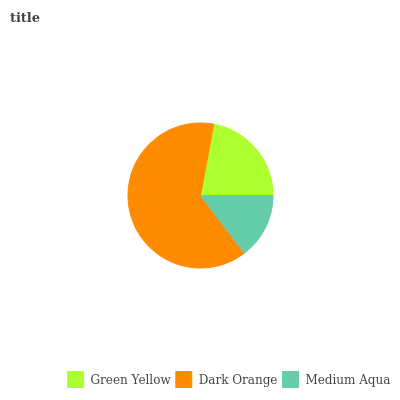Is Medium Aqua the minimum?
Answer yes or no. Yes. Is Dark Orange the maximum?
Answer yes or no. Yes. Is Dark Orange the minimum?
Answer yes or no. No. Is Medium Aqua the maximum?
Answer yes or no. No. Is Dark Orange greater than Medium Aqua?
Answer yes or no. Yes. Is Medium Aqua less than Dark Orange?
Answer yes or no. Yes. Is Medium Aqua greater than Dark Orange?
Answer yes or no. No. Is Dark Orange less than Medium Aqua?
Answer yes or no. No. Is Green Yellow the high median?
Answer yes or no. Yes. Is Green Yellow the low median?
Answer yes or no. Yes. Is Dark Orange the high median?
Answer yes or no. No. Is Medium Aqua the low median?
Answer yes or no. No. 